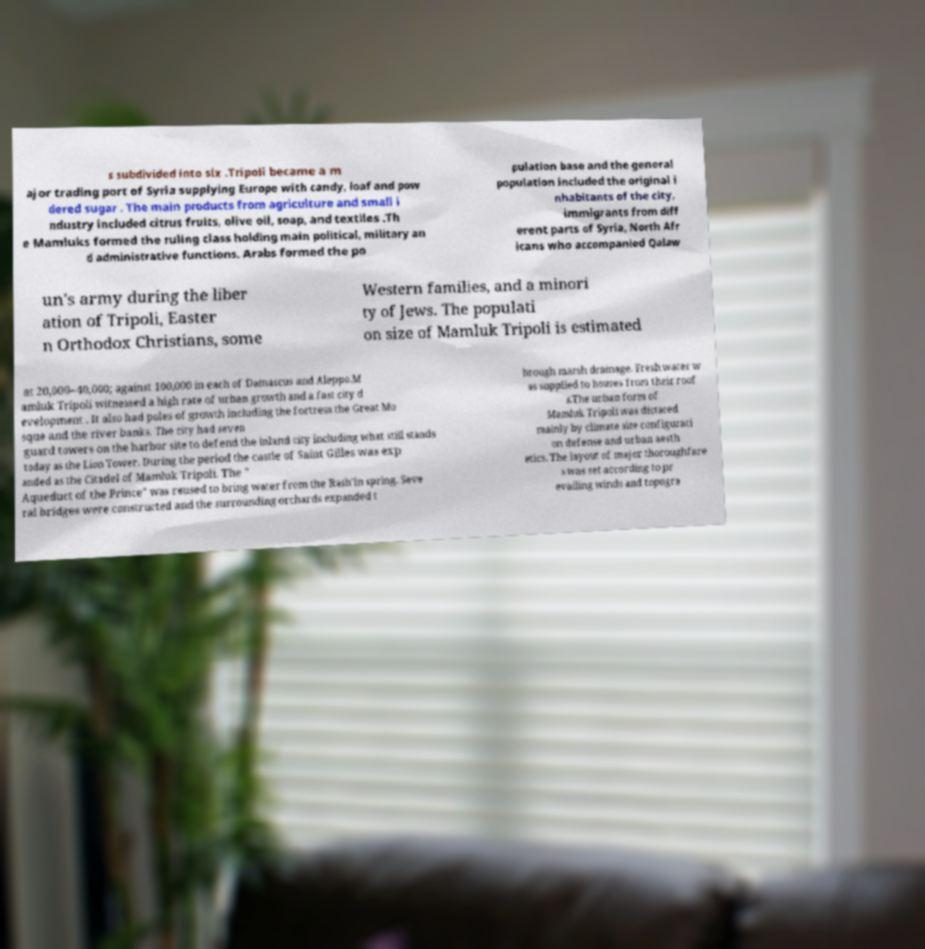Can you read and provide the text displayed in the image?This photo seems to have some interesting text. Can you extract and type it out for me? s subdivided into six .Tripoli became a m ajor trading port of Syria supplying Europe with candy, loaf and pow dered sugar . The main products from agriculture and small i ndustry included citrus fruits, olive oil, soap, and textiles .Th e Mamluks formed the ruling class holding main political, military an d administrative functions. Arabs formed the po pulation base and the general population included the original i nhabitants of the city, immigrants from diff erent parts of Syria, North Afr icans who accompanied Qalaw un's army during the liber ation of Tripoli, Easter n Orthodox Christians, some Western families, and a minori ty of Jews. The populati on size of Mamluk Tripoli is estimated at 20,000–40,000; against 100,000 in each of Damascus and Aleppo.M amluk Tripoli witnessed a high rate of urban growth and a fast city d evelopment . It also had poles of growth including the fortress the Great Mo sque and the river banks. The city had seven guard towers on the harbor site to defend the inland city including what still stands today as the Lion Tower. During the period the castle of Saint Gilles was exp anded as the Citadel of Mamluk Tripoli. The " Aqueduct of the Prince" was reused to bring water from the Rash'in spring. Seve ral bridges were constructed and the surrounding orchards expanded t hrough marsh drainage. Fresh water w as supplied to houses from their roof s.The urban form of Mamluk Tripoli was dictated mainly by climate site configurati on defense and urban aesth etics. The layout of major thoroughfare s was set according to pr evailing winds and topogra 